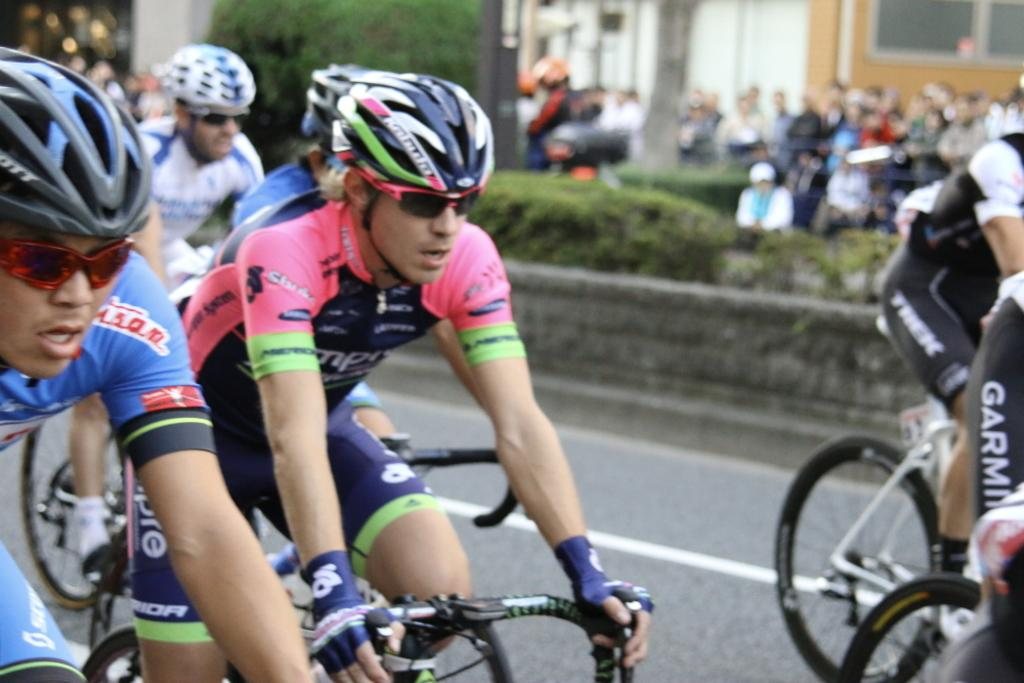What are the people in the image holding? People are holding bicycles in the image. What safety equipment are the people wearing? The people are wearing helmets. Can you describe the background of the image? The background of the image is blurry, but there is a tree, plants, and people visible. How many boats can be seen in the image? There are no boats present in the image. What is the woman's name in the image? There is no woman present in the image. 